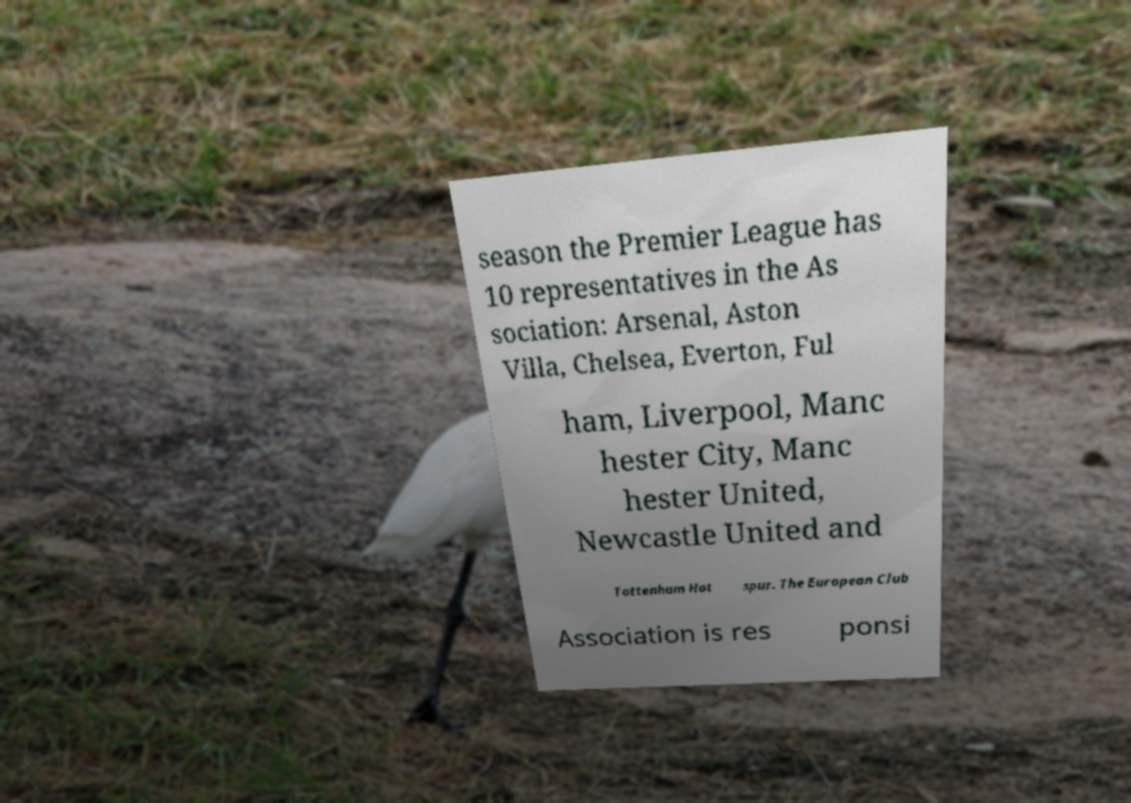For documentation purposes, I need the text within this image transcribed. Could you provide that? season the Premier League has 10 representatives in the As sociation: Arsenal, Aston Villa, Chelsea, Everton, Ful ham, Liverpool, Manc hester City, Manc hester United, Newcastle United and Tottenham Hot spur. The European Club Association is res ponsi 